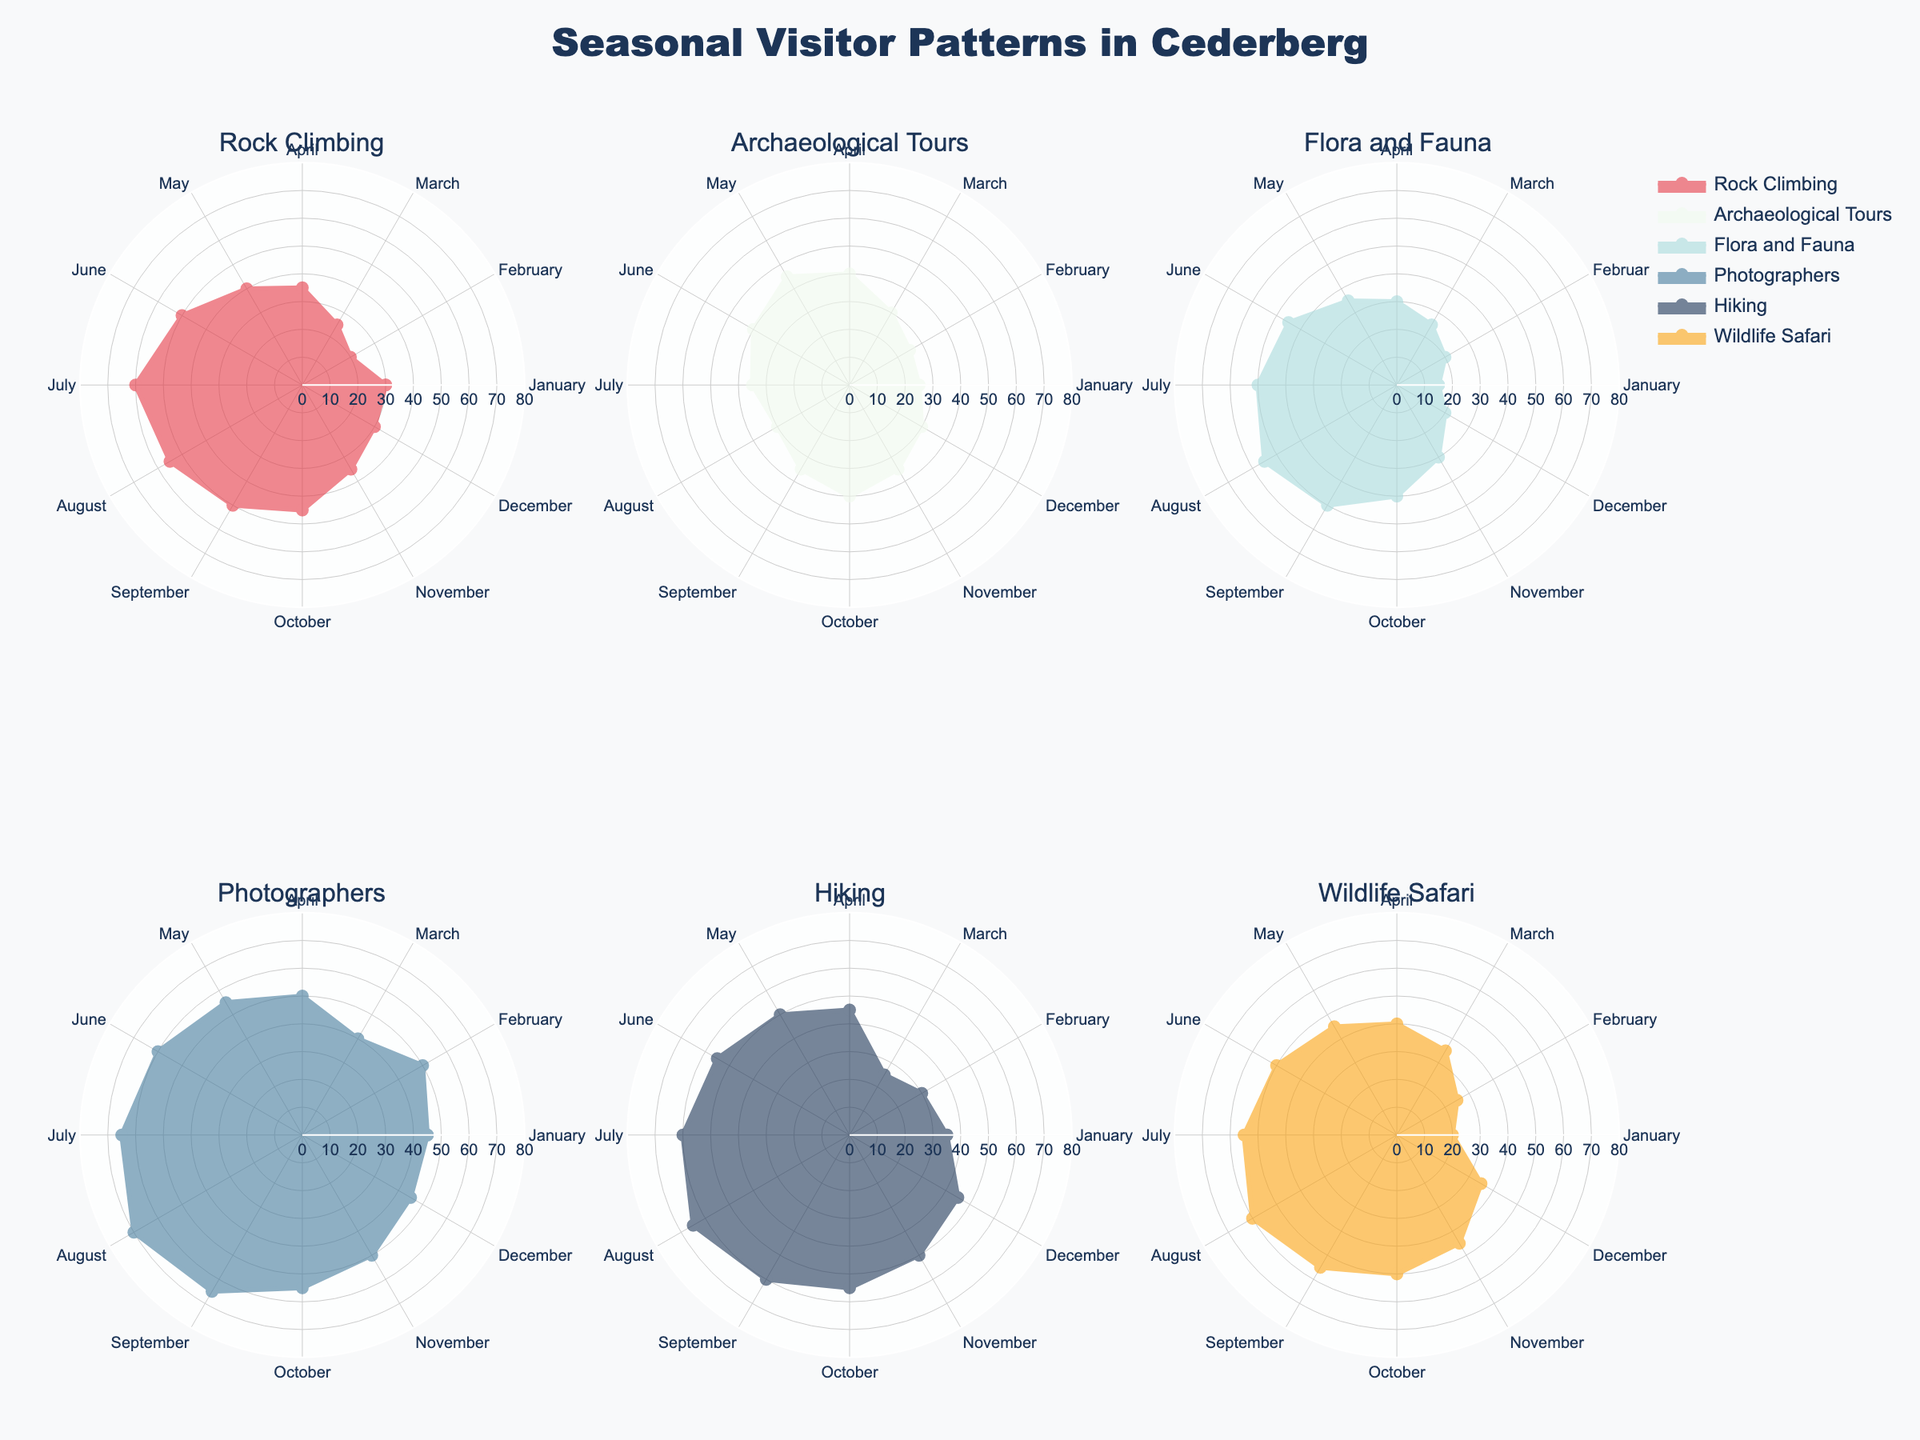what is the title of the figure? The title is usually placed at the top center of the figure. Here, the title reads "Seasonal Visitor Patterns in Cederberg"
Answer: Seasonal Visitor Patterns in Cederberg which activity sees its highest visitors in August? By looking at the radar charts for each activity, Flora and Fauna has its peak in August with 55 visitors.
Answer: Flora and Fauna in which month do Rock Climbing and Photographers have equal visitors? Look at the radar charts and compare the months where Rock Climbing and Photographers intersect. They both have 45 visitors in October.
Answer: October how many activities have more than 50 visitors in July? By examining the radar charts for July, it's seen that Rock Climbing (60), Photographers (65), Hiking (60), and Wildlife Safari (55) all have more than 50 visitors.
Answer: Four which activity has the most variation in visitor numbers throughout the year? Variation can be assessed by the range of values for each activity. Photographers have a range between 40 and 70, the highest variation compared to others.
Answer: Photographers what is the difference in visitors for Wildlife Safari between January and June? From the chart, Wildlife Safari has 20 visitors in January and 50 in June. Calculating the difference gives 50 - 20 = 30.
Answer: 30 how does Flora and Fauna's lowest visitor month compare with Rock Climbing's highest visitor month? Flora and Fauna's lowest is January with 15 visitors, while Rock Climbing's highest is July with 60 visitors. The difference is 60 - 15 = 45.
Answer: 45 which month has the lowest total visitors across all activities? Summing all the visitors for each month, January has the least total with (30+25+15+45+35+20) = 170 visitors.
Answer: January is there any activity that consistently has more than 30 visitors every month? Analyze each radar chart to check for activities that meet this criterion. Rock Climbing and Photographers consistently have more than 30 visitors each month.
Answer: Rock Climbing, Photographers how many activities peak in June? By inspecting each activity's radar chart, it's seen that Rock Climbing (50), Flora and Fauna (45), Photographers (60), and Hiking (55) peak in June.
Answer: Four which activity has its peak visitor count in February? From the radar charts, Photographers have their highest visitor count in February with 50 visitors.
Answer: Photographers 